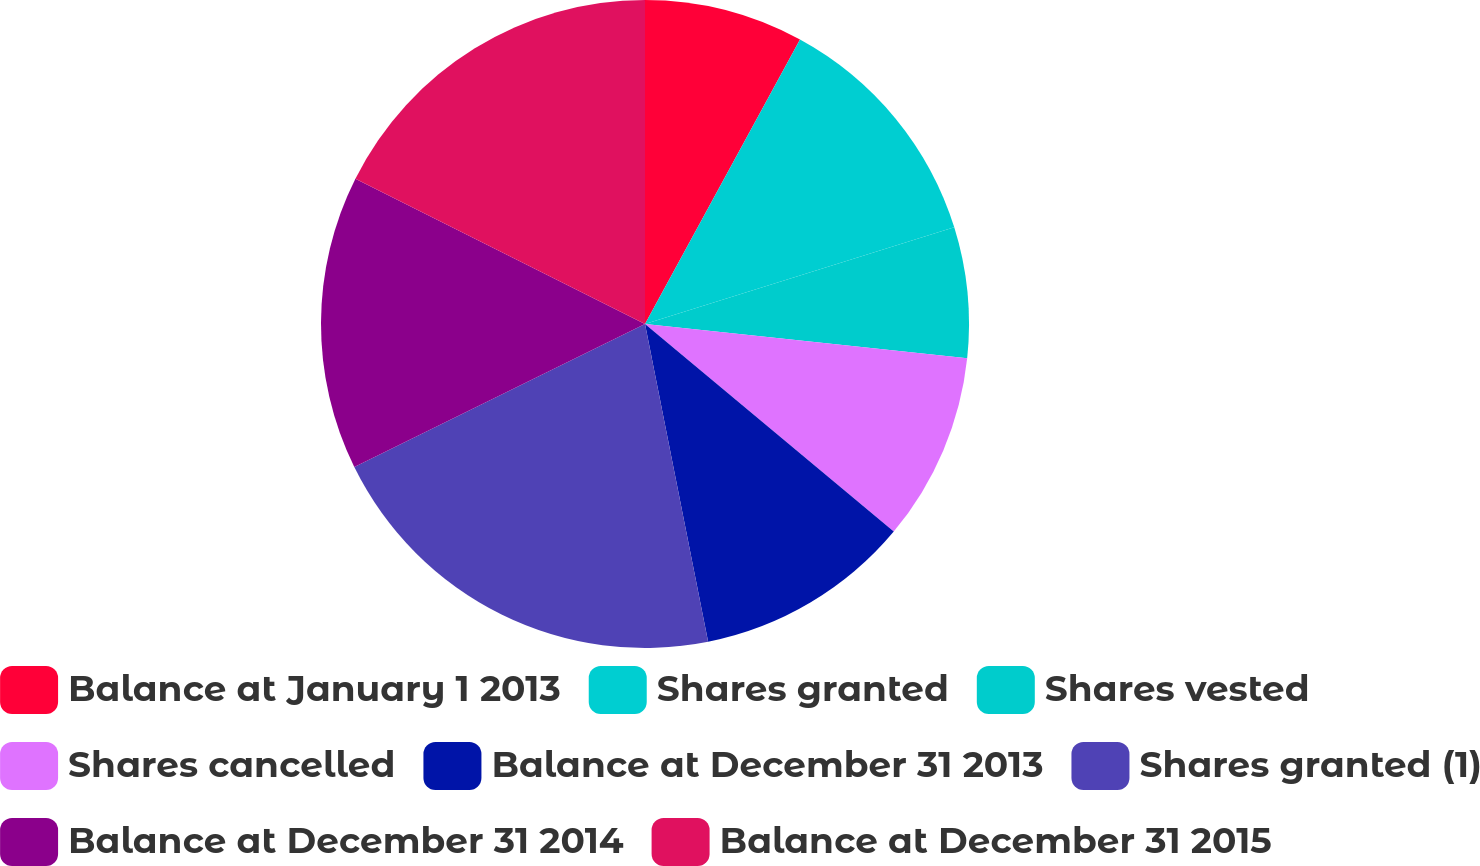Convert chart. <chart><loc_0><loc_0><loc_500><loc_500><pie_chart><fcel>Balance at January 1 2013<fcel>Shares granted<fcel>Shares vested<fcel>Shares cancelled<fcel>Balance at December 31 2013<fcel>Shares granted (1)<fcel>Balance at December 31 2014<fcel>Balance at December 31 2015<nl><fcel>7.94%<fcel>12.24%<fcel>6.51%<fcel>9.38%<fcel>10.81%<fcel>20.84%<fcel>14.68%<fcel>17.6%<nl></chart> 